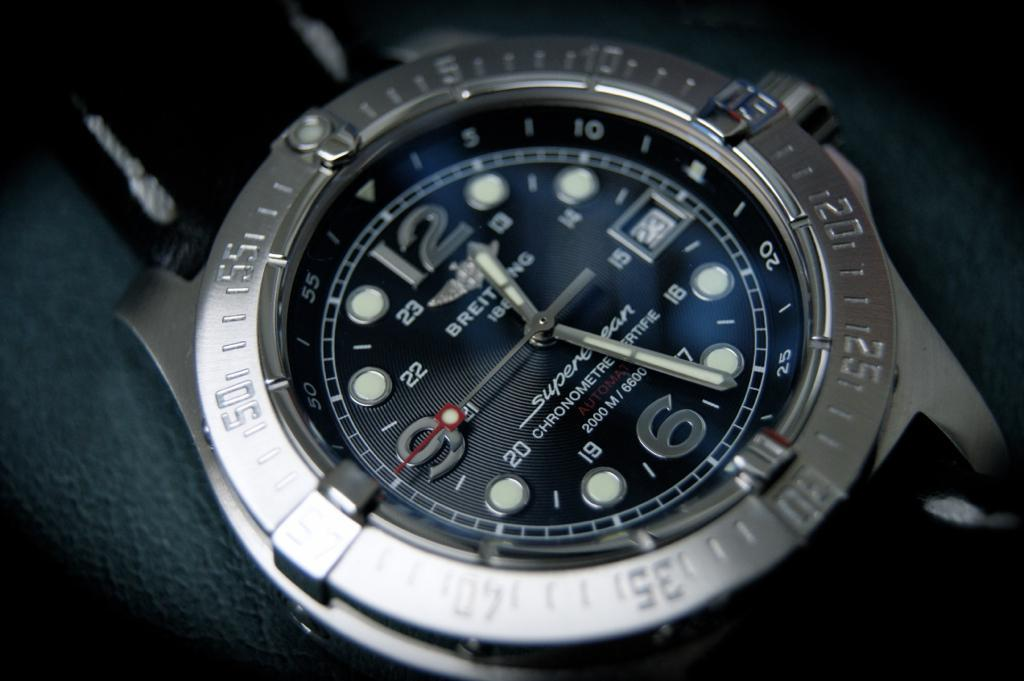Provide a one-sentence caption for the provided image. The grey and black watch displays a time of 12:26. 